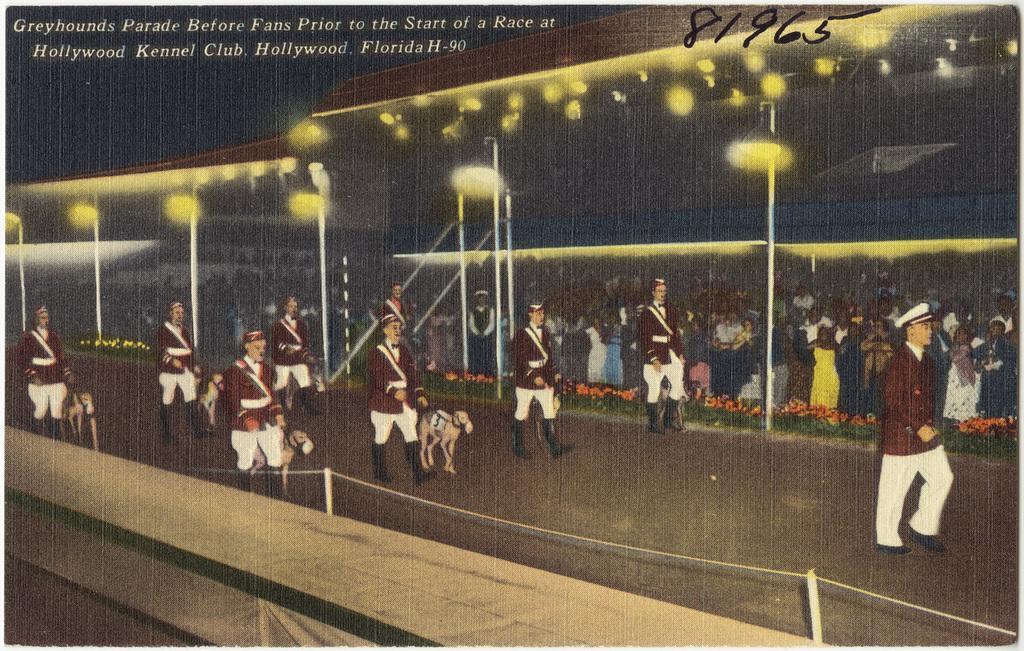In one or two sentences, can you explain what this image depicts? In the picture we can see an art of a people's wearing maroon color uniforms are walking on the road and we can see an animals are also walking along with them. In the background, we can see the light poles, few people standing there and we can see the tents. Here we can see the edited text on the top left side of the image. 